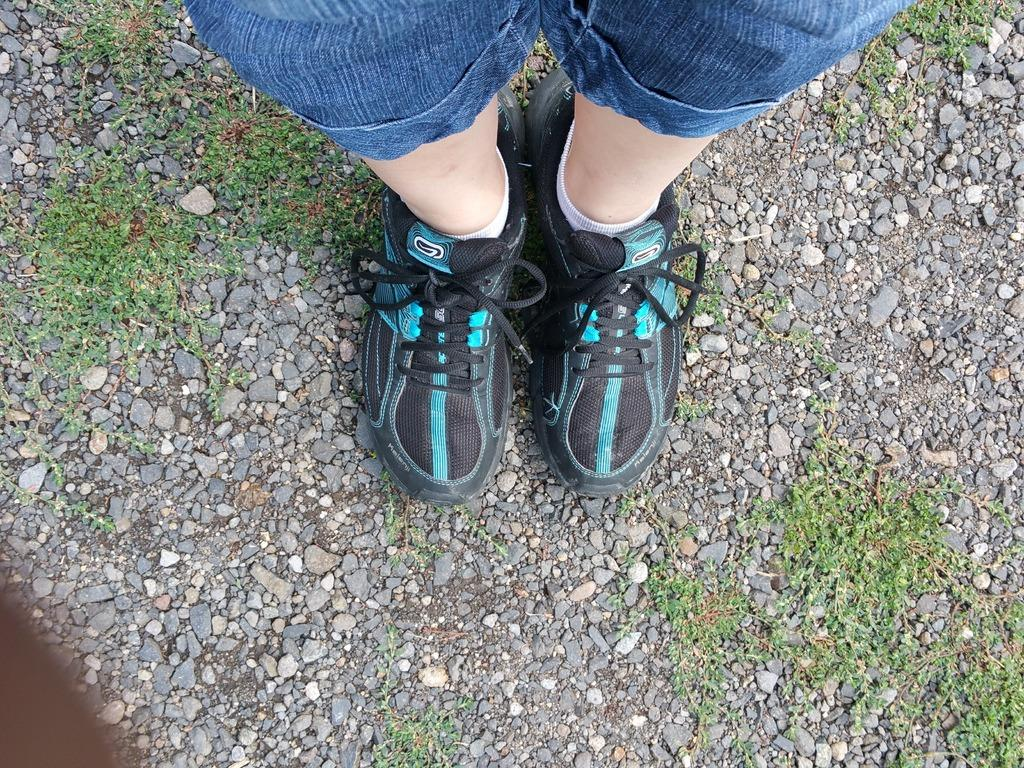What can be seen in the foreground of the image? There are two legs of a person in the foreground of the image. What type of footwear is the person wearing? The person is wearing shoes. What type of surface is the person standing on? The legs are standing on land. What type of vegetation is present around the legs? There is grass around the legs. What type of natural objects are near the legs? There are stones near the legs. What type of quince is being used to start a fire near the legs in the image? There is no quince or fire present in the image; it only shows a person's legs standing on land with grass and stones nearby. 